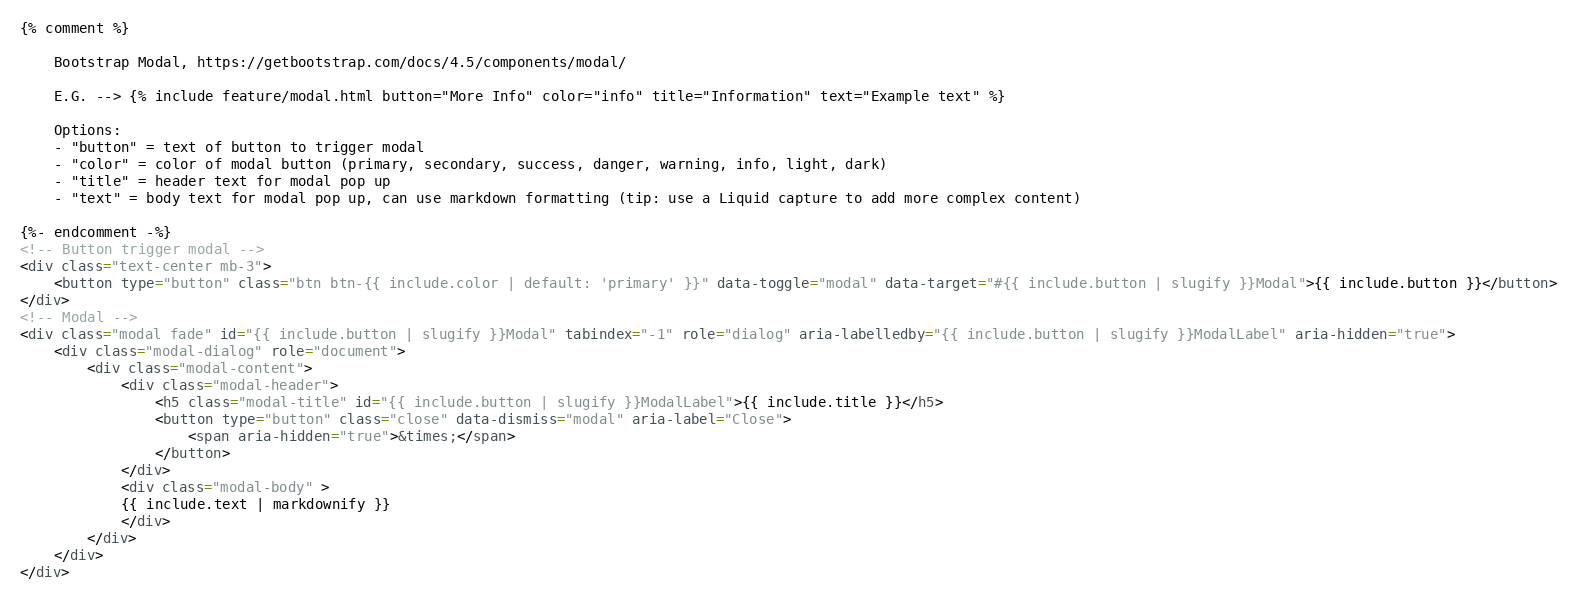<code> <loc_0><loc_0><loc_500><loc_500><_HTML_>{% comment %}

    Bootstrap Modal, https://getbootstrap.com/docs/4.5/components/modal/

    E.G. --> {% include feature/modal.html button="More Info" color="info" title="Information" text="Example text" %}

    Options: 
    - "button" = text of button to trigger modal
    - "color" = color of modal button (primary, secondary, success, danger, warning, info, light, dark)
    - "title" = header text for modal pop up
    - "text" = body text for modal pop up, can use markdown formatting (tip: use a Liquid capture to add more complex content)

{%- endcomment -%}
<!-- Button trigger modal -->
<div class="text-center mb-3">
    <button type="button" class="btn btn-{{ include.color | default: 'primary' }}" data-toggle="modal" data-target="#{{ include.button | slugify }}Modal">{{ include.button }}</button>
</div>
<!-- Modal -->
<div class="modal fade" id="{{ include.button | slugify }}Modal" tabindex="-1" role="dialog" aria-labelledby="{{ include.button | slugify }}ModalLabel" aria-hidden="true">
    <div class="modal-dialog" role="document">
        <div class="modal-content">
            <div class="modal-header">
                <h5 class="modal-title" id="{{ include.button | slugify }}ModalLabel">{{ include.title }}</h5>
                <button type="button" class="close" data-dismiss="modal" aria-label="Close">
                    <span aria-hidden="true">&times;</span>
                </button>
            </div>
            <div class="modal-body" >
            {{ include.text | markdownify }}
            </div>
        </div>
    </div>
</div>
</code> 